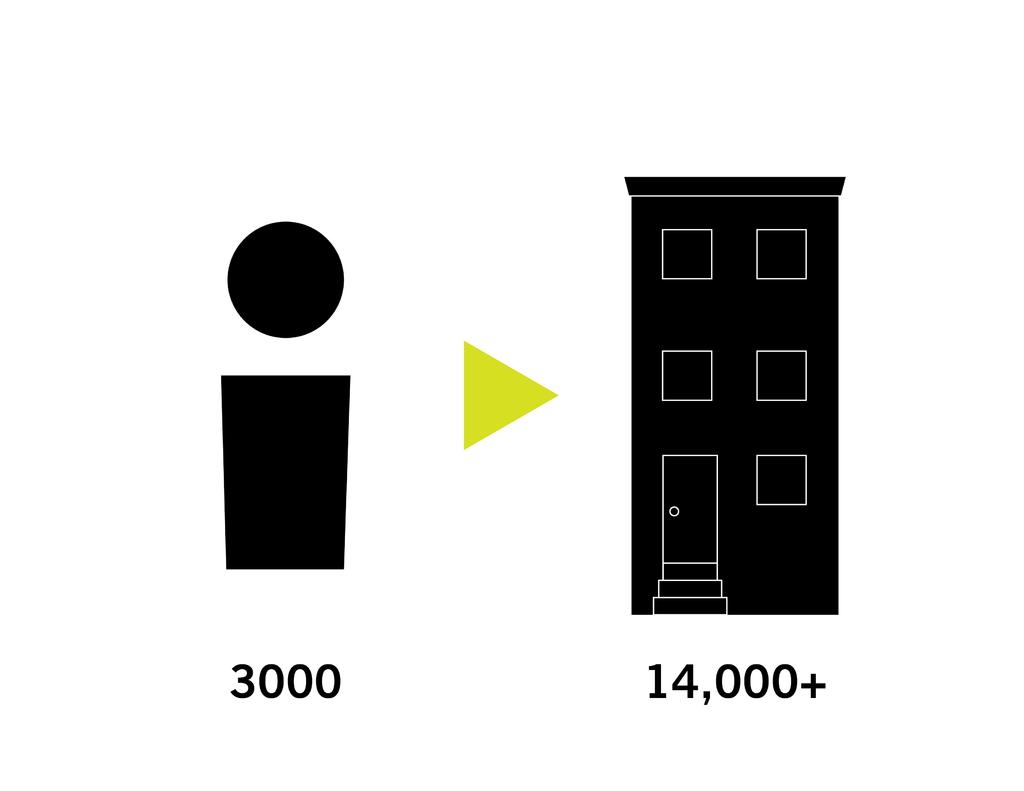<image>
Present a compact description of the photo's key features. A figure has 3000 under it and a building next to it. 